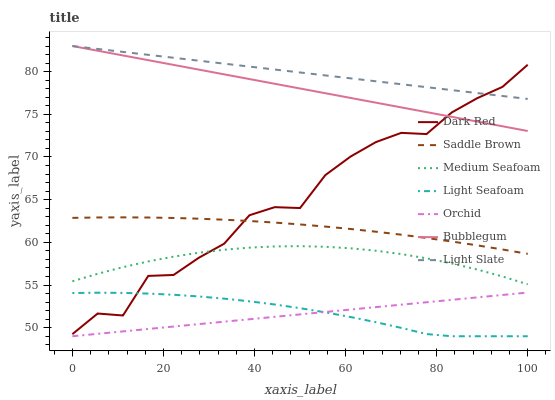Does Orchid have the minimum area under the curve?
Answer yes or no. Yes. Does Light Slate have the maximum area under the curve?
Answer yes or no. Yes. Does Dark Red have the minimum area under the curve?
Answer yes or no. No. Does Dark Red have the maximum area under the curve?
Answer yes or no. No. Is Orchid the smoothest?
Answer yes or no. Yes. Is Dark Red the roughest?
Answer yes or no. Yes. Is Bubblegum the smoothest?
Answer yes or no. No. Is Bubblegum the roughest?
Answer yes or no. No. Does Light Seafoam have the lowest value?
Answer yes or no. Yes. Does Dark Red have the lowest value?
Answer yes or no. No. Does Bubblegum have the highest value?
Answer yes or no. Yes. Does Dark Red have the highest value?
Answer yes or no. No. Is Orchid less than Dark Red?
Answer yes or no. Yes. Is Bubblegum greater than Saddle Brown?
Answer yes or no. Yes. Does Bubblegum intersect Light Slate?
Answer yes or no. Yes. Is Bubblegum less than Light Slate?
Answer yes or no. No. Is Bubblegum greater than Light Slate?
Answer yes or no. No. Does Orchid intersect Dark Red?
Answer yes or no. No. 